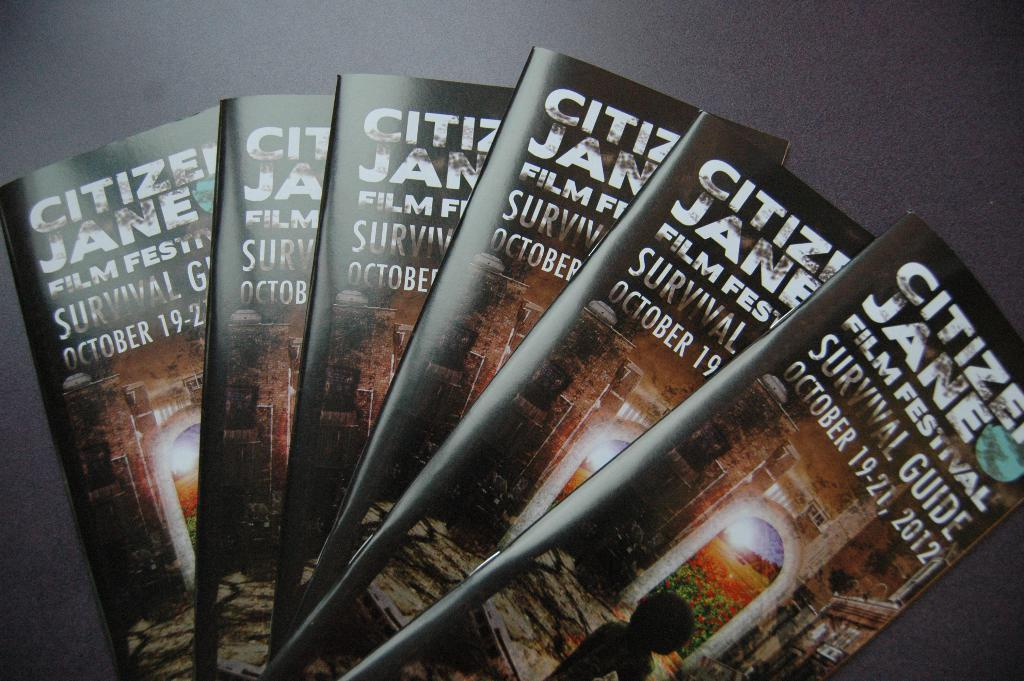<image>
Create a compact narrative representing the image presented. Brochures for the Citizens Jane film festival in October 